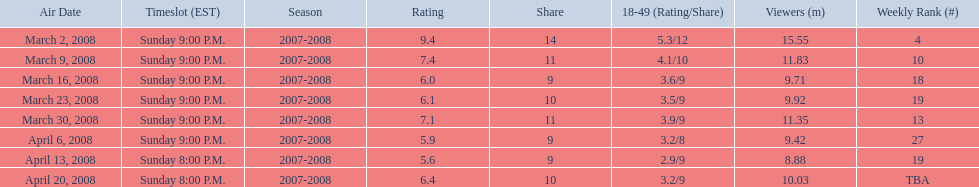What time slot did the show have for its first 6 episodes? Sunday 9:00 P.M. 